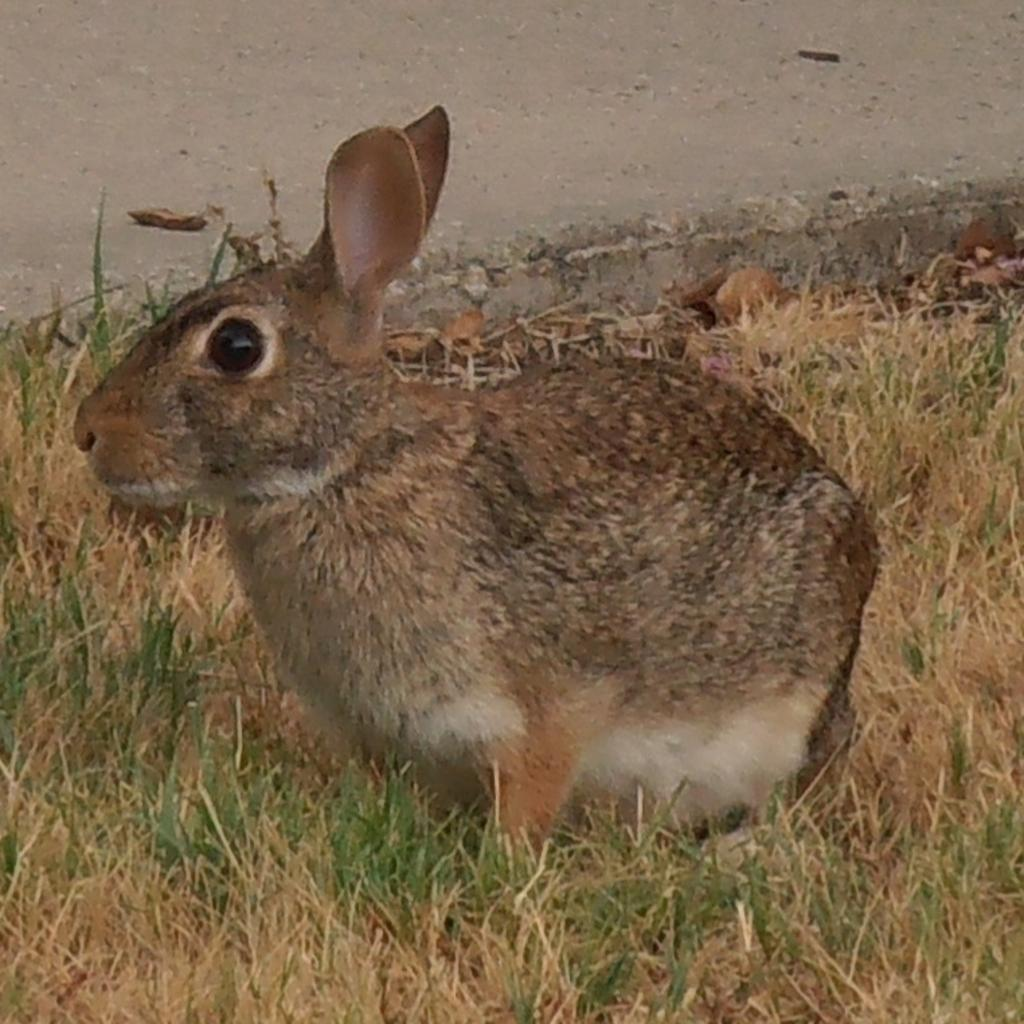What type of animal is present in the image? There is an animal in the image, but the specific type of animal is not mentioned in the facts. Can you describe the animal's position in the image? The animal is on the ground in the image. What type of vegetation is present on the ground in the image? There is grass on the ground in the image. What type of wine is the animal drinking in the image? There is no wine present in the image; it features an animal on the ground with grass. Can you tell me how many credit cards the animal has in the image? There is no mention of credit cards or any financial transactions in the image. 